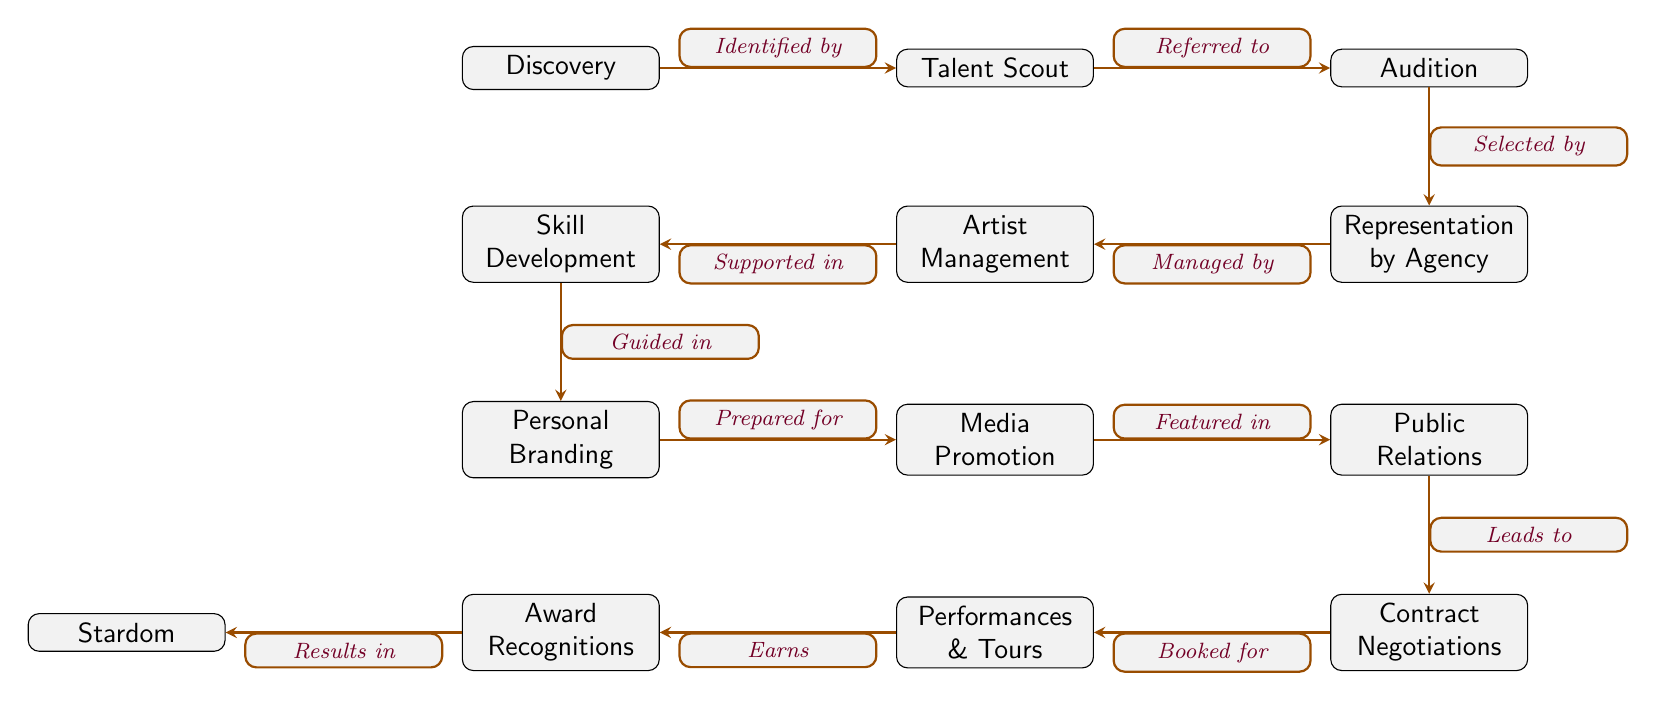What is the first step in the career progression shown in the diagram? The first step is the "Discovery" node, which serves as the starting point for an artist's career.
Answer: Discovery How many nodes are present in the diagram? By counting all distinct nodes in the diagram, there are a total of 12 unique components depicting the stages of an artist's career.
Answer: 12 What does "Represented by" lead to in the diagram? The arrow from "Representation by Agency" points to "Artist Management," indicating that representation leads to management responsibilities for the artist.
Answer: Artist Management Which node is the ultimate goal in the career progression? The last node in the flow, which represents the ultimate achievement in an artist's career, is "Stardom."
Answer: Stardom What type of support is indicated between "Management" and "Development"? The arrow from "Management" to "Development" is labeled "Supported in," implying that management provides assistance during the development phase of the artist's career.
Answer: Supported in How does the "Branding" node interact with the "Promotion" node? The arrow labeled "Prepared for" from "Branding" to "Promotion" shows that personal branding prepares the artist for subsequent media promotions.
Answer: Prepared for What is the relationship between "Contracts" and "Performances"? The arrow indicates that "Contracts" leads to "Performances & Tours," implying that once contracts are negotiated, the artist can be booked for performances.
Answer: Booked for What is necessary before an artist achieves "Recognition"? The node labeled "Performances & Tours" leads to "Award Recognitions," indicating that performing is necessary before gaining recognition in the industry.
Answer: Performances & Tours What role does "Public Relations" play in the diagram? The arrow leading from "Media Promotion" to "Public Relations" shows that media promotion leads into public relations efforts for the artist's visibility and image.
Answer: Leads to 